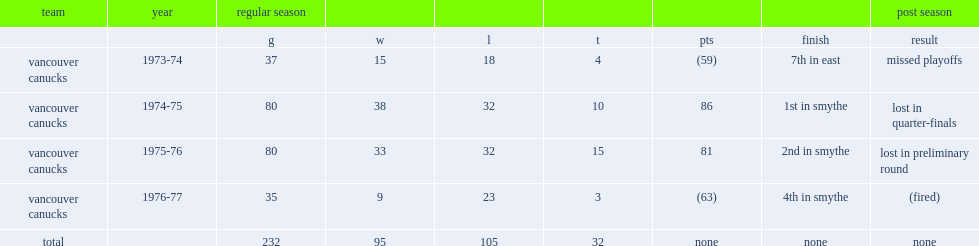Write the full table. {'header': ['team', 'year', 'regular season', '', '', '', '', '', 'post season'], 'rows': [['', '', 'g', 'w', 'l', 't', 'pts', 'finish', 'result'], ['vancouver canucks', '1973-74', '37', '15', '18', '4', '(59)', '7th in east', 'missed playoffs'], ['vancouver canucks', '1974-75', '80', '38', '32', '10', '86', '1st in smythe', 'lost in quarter-finals'], ['vancouver canucks', '1975-76', '80', '33', '32', '15', '81', '2nd in smythe', 'lost in preliminary round'], ['vancouver canucks', '1976-77', '35', '9', '23', '3', '(63)', '4th in smythe', '(fired)'], ['total', '', '232', '95', '105', '32', 'none', 'none', 'none']]} How many games did phil maloney coach the vancouver canucks? 232.0. 